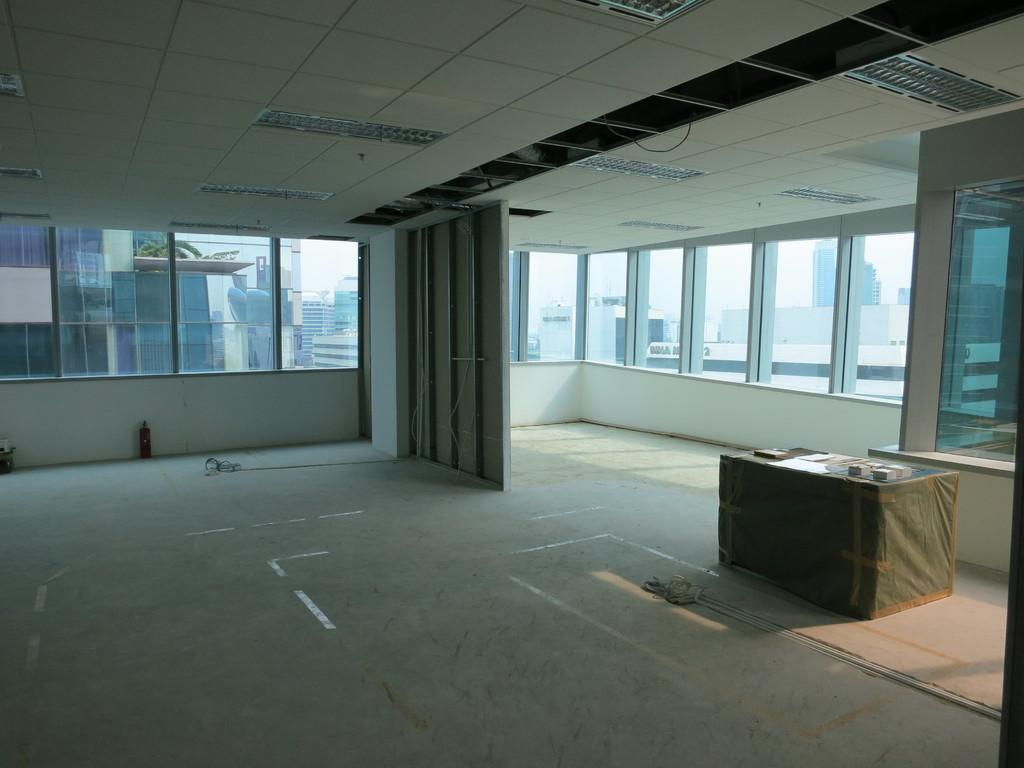Where was the image taken? The image was taken inside a room. What can be seen in the middle of the room? There are windows in the middle of the room. What is located at the top of the room? There are lights at the top of the room. What is on the right side of the room? There is a table on the right side of the room. What unit of measurement is used to determine the temperature in the room? The image does not provide information about the temperature or any unit of measurement for it. 